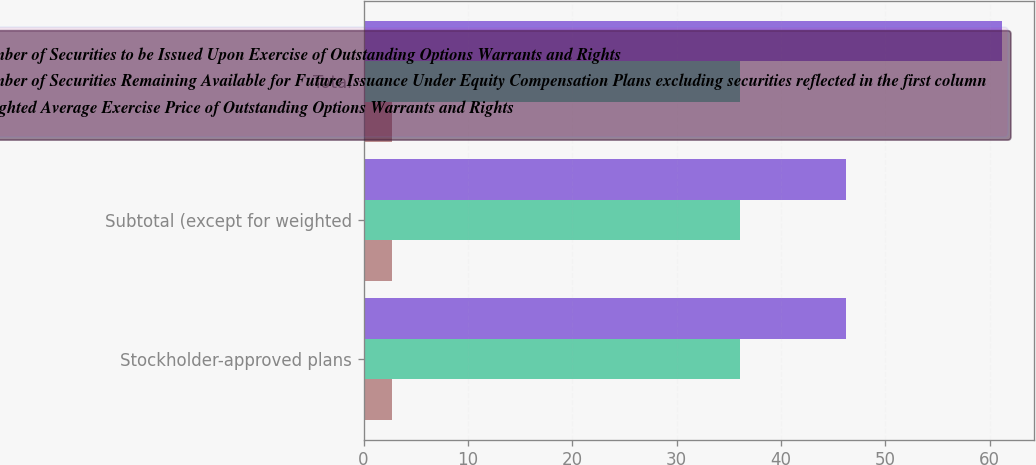<chart> <loc_0><loc_0><loc_500><loc_500><stacked_bar_chart><ecel><fcel>Stockholder-approved plans<fcel>Subtotal (except for weighted<fcel>Total<nl><fcel>Number of Securities to be Issued Upon Exercise of Outstanding Options Warrants and Rights<fcel>2.7<fcel>2.7<fcel>2.7<nl><fcel>Number of Securities Remaining Available for Future Issuance Under Equity Compensation Plans excluding securities reflected in the first column<fcel>36.11<fcel>36.11<fcel>36.11<nl><fcel>Weighted Average Exercise Price of Outstanding Options Warrants and Rights<fcel>46.2<fcel>46.2<fcel>61.2<nl></chart> 